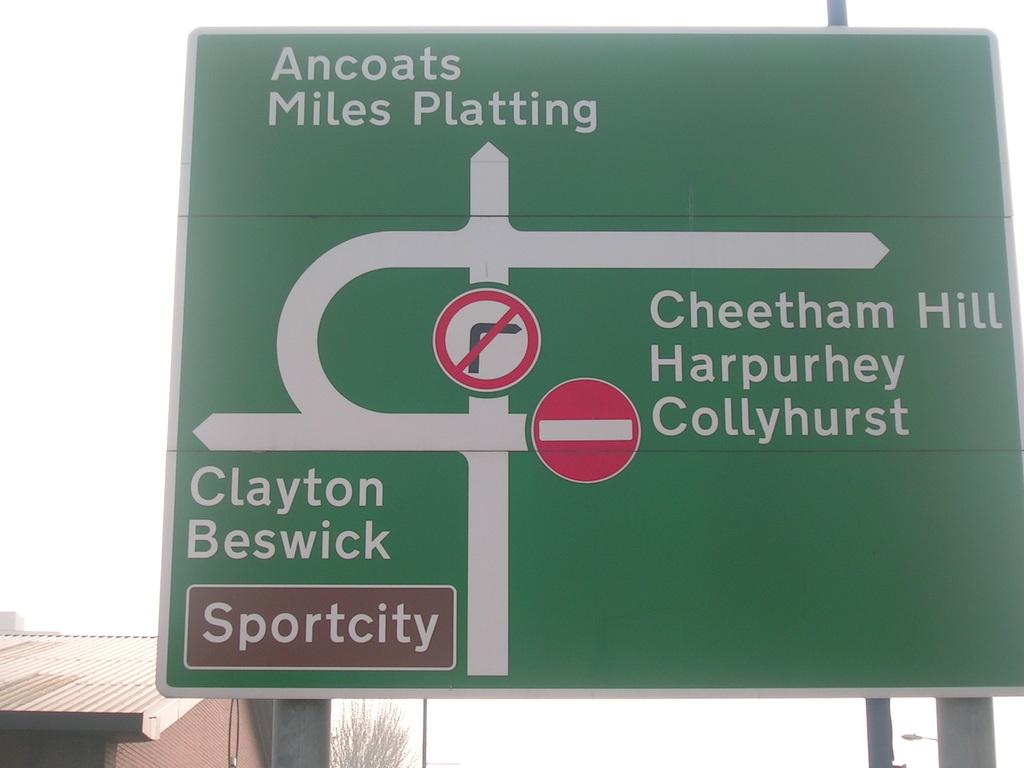<image>
Provide a brief description of the given image. A large green sign shows directions to Sportcity. 